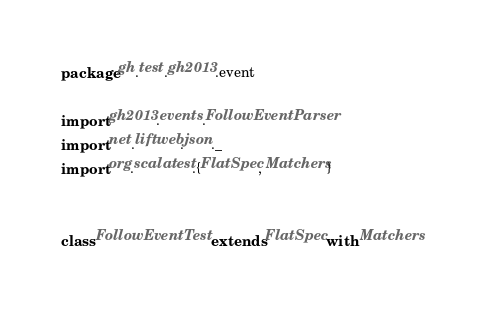Convert code to text. <code><loc_0><loc_0><loc_500><loc_500><_Scala_>package gh.test.gh2013.event

import gh2013.events.FollowEventParser
import net.liftweb.json._
import org.scalatest.{FlatSpec, Matchers}


class FollowEventTest extends FlatSpec with Matchers</code> 